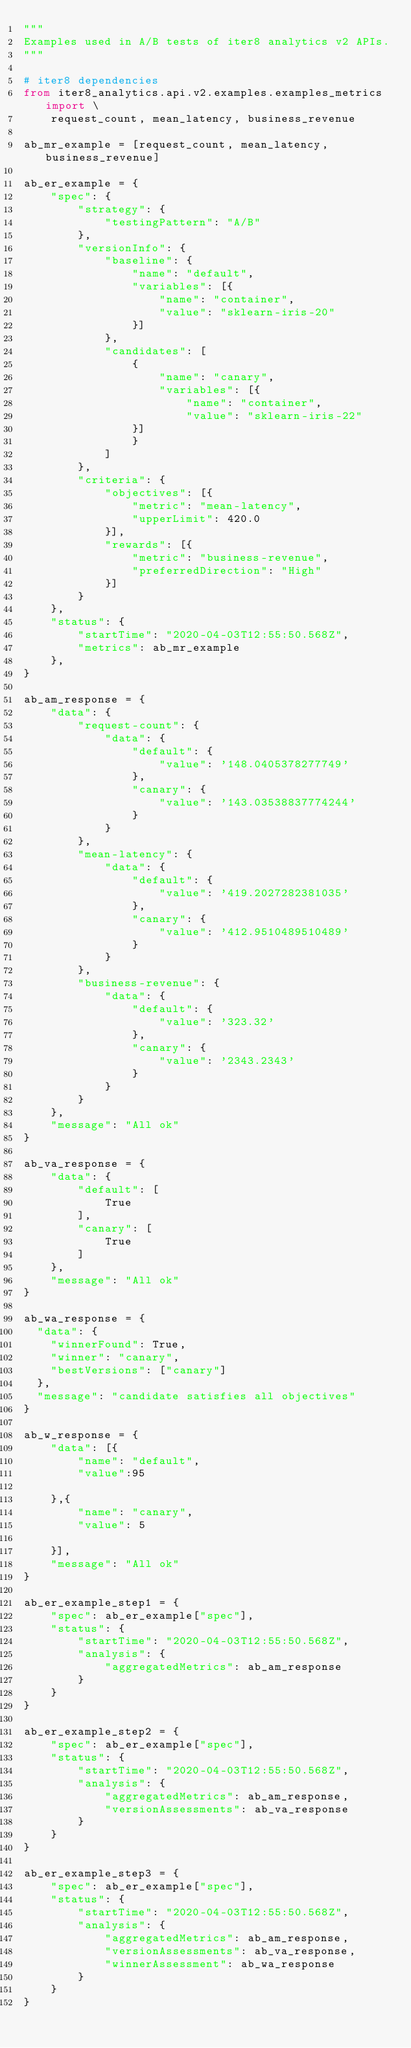<code> <loc_0><loc_0><loc_500><loc_500><_Python_>"""
Examples used in A/B tests of iter8 analytics v2 APIs.
"""

# iter8 dependencies
from iter8_analytics.api.v2.examples.examples_metrics import \
    request_count, mean_latency, business_revenue

ab_mr_example = [request_count, mean_latency, business_revenue]

ab_er_example = {
    "spec": {
        "strategy": {
            "testingPattern": "A/B"
        },
        "versionInfo": {
            "baseline": {
                "name": "default",
                "variables": [{
                    "name": "container",
                    "value": "sklearn-iris-20"
                }]
            },
            "candidates": [
                {
                    "name": "canary",
                    "variables": [{
                        "name": "container",
                        "value": "sklearn-iris-22"
                }]
                }
            ]
        },
        "criteria": {
            "objectives": [{
                "metric": "mean-latency",
                "upperLimit": 420.0
            }],
            "rewards": [{
                "metric": "business-revenue",
                "preferredDirection": "High"
            }]
        }
    },
    "status": {
        "startTime": "2020-04-03T12:55:50.568Z",
        "metrics": ab_mr_example
    },
}

ab_am_response = {
    "data": {
        "request-count": {
            "data": {
                "default": {
                    "value": '148.0405378277749'
                },
                "canary": {
                    "value": '143.03538837774244'
                }
            }
        },
        "mean-latency": {
            "data": {
                "default": {
                    "value": '419.2027282381035'
                },
                "canary": {
                    "value": '412.9510489510489'
                }
            }
        },
        "business-revenue": {
            "data": {
                "default": {
                    "value": '323.32'
                },
                "canary": {
                    "value": '2343.2343'
                }
            }
        }
    },
    "message": "All ok"
}

ab_va_response = {
    "data": {
        "default": [
            True
        ],
        "canary": [
            True
        ]
    },
    "message": "All ok"
}

ab_wa_response = {
  "data": {
    "winnerFound": True,
    "winner": "canary",
    "bestVersions": ["canary"]
  },
  "message": "candidate satisfies all objectives"
}

ab_w_response = {
    "data": [{
        "name": "default",
        "value":95

    },{
        "name": "canary",
        "value": 5

    }],
    "message": "All ok"
}

ab_er_example_step1 = {
    "spec": ab_er_example["spec"],
    "status": {
        "startTime": "2020-04-03T12:55:50.568Z",
        "analysis": {
            "aggregatedMetrics": ab_am_response
        }
    }
}

ab_er_example_step2 = {
    "spec": ab_er_example["spec"],
    "status": {
        "startTime": "2020-04-03T12:55:50.568Z",
        "analysis": {
            "aggregatedMetrics": ab_am_response,
            "versionAssessments": ab_va_response
        }
    }
}

ab_er_example_step3 = {
    "spec": ab_er_example["spec"],
    "status": {
        "startTime": "2020-04-03T12:55:50.568Z",
        "analysis": {
            "aggregatedMetrics": ab_am_response,
            "versionAssessments": ab_va_response,
            "winnerAssessment": ab_wa_response
        }
    }
}
</code> 